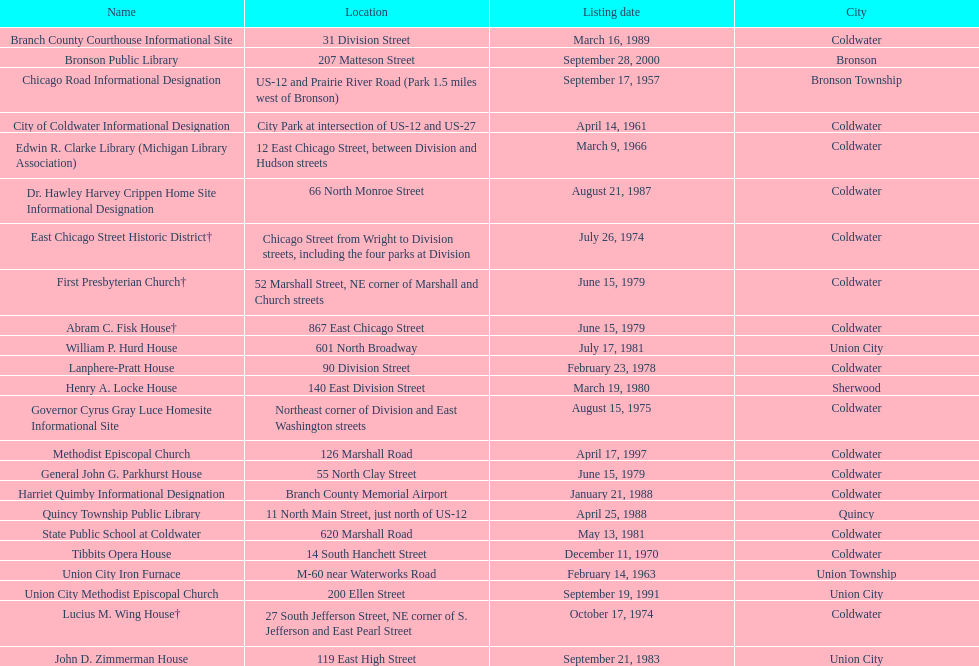How many historic sites are listed in coldwater? 15. 